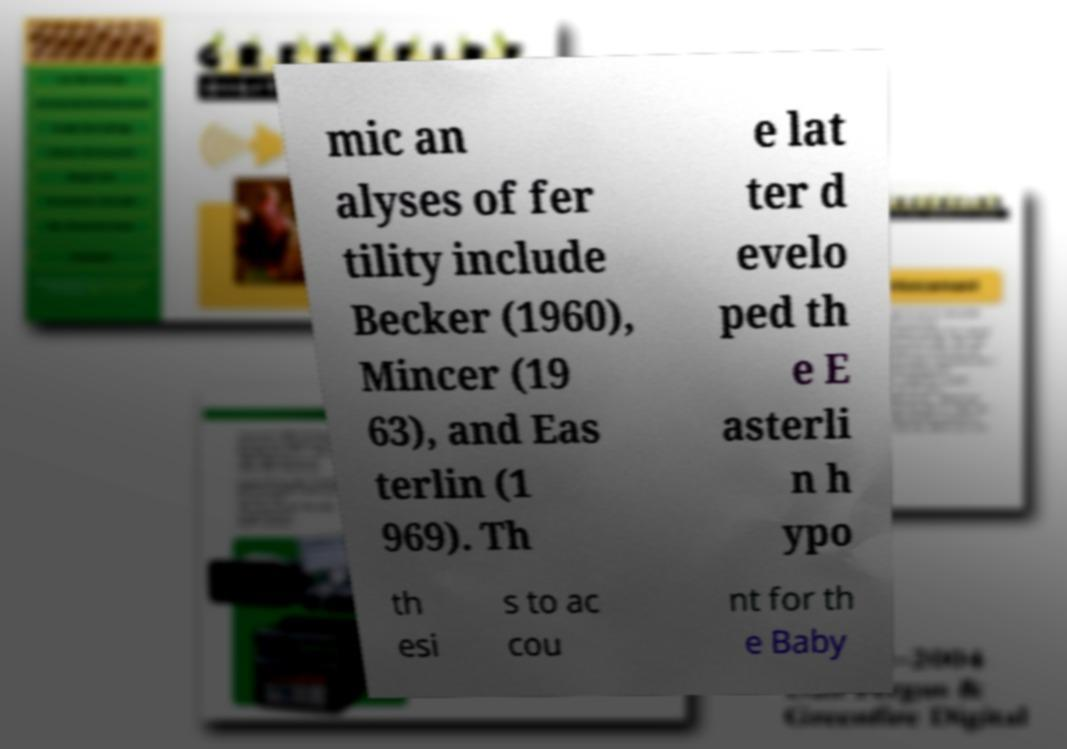What messages or text are displayed in this image? I need them in a readable, typed format. mic an alyses of fer tility include Becker (1960), Mincer (19 63), and Eas terlin (1 969). Th e lat ter d evelo ped th e E asterli n h ypo th esi s to ac cou nt for th e Baby 